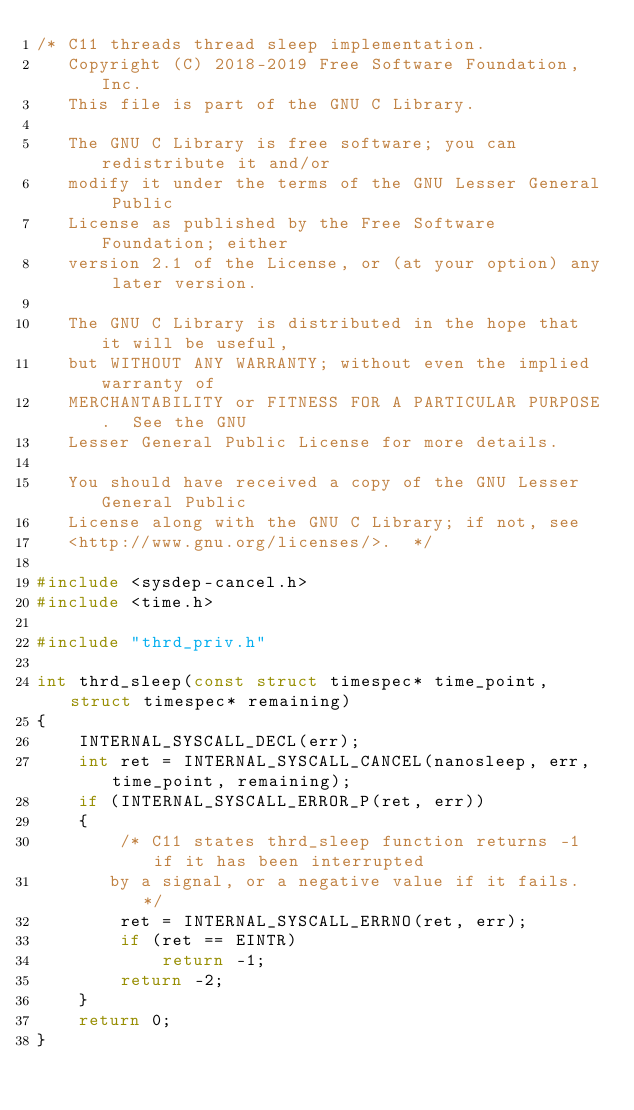<code> <loc_0><loc_0><loc_500><loc_500><_C_>/* C11 threads thread sleep implementation.
   Copyright (C) 2018-2019 Free Software Foundation, Inc.
   This file is part of the GNU C Library.

   The GNU C Library is free software; you can redistribute it and/or
   modify it under the terms of the GNU Lesser General Public
   License as published by the Free Software Foundation; either
   version 2.1 of the License, or (at your option) any later version.

   The GNU C Library is distributed in the hope that it will be useful,
   but WITHOUT ANY WARRANTY; without even the implied warranty of
   MERCHANTABILITY or FITNESS FOR A PARTICULAR PURPOSE.  See the GNU
   Lesser General Public License for more details.

   You should have received a copy of the GNU Lesser General Public
   License along with the GNU C Library; if not, see
   <http://www.gnu.org/licenses/>.  */

#include <sysdep-cancel.h>
#include <time.h>

#include "thrd_priv.h"

int thrd_sleep(const struct timespec* time_point, struct timespec* remaining)
{
    INTERNAL_SYSCALL_DECL(err);
    int ret = INTERNAL_SYSCALL_CANCEL(nanosleep, err, time_point, remaining);
    if (INTERNAL_SYSCALL_ERROR_P(ret, err))
    {
        /* C11 states thrd_sleep function returns -1 if it has been interrupted
       by a signal, or a negative value if it fails.  */
        ret = INTERNAL_SYSCALL_ERRNO(ret, err);
        if (ret == EINTR)
            return -1;
        return -2;
    }
    return 0;
}
</code> 